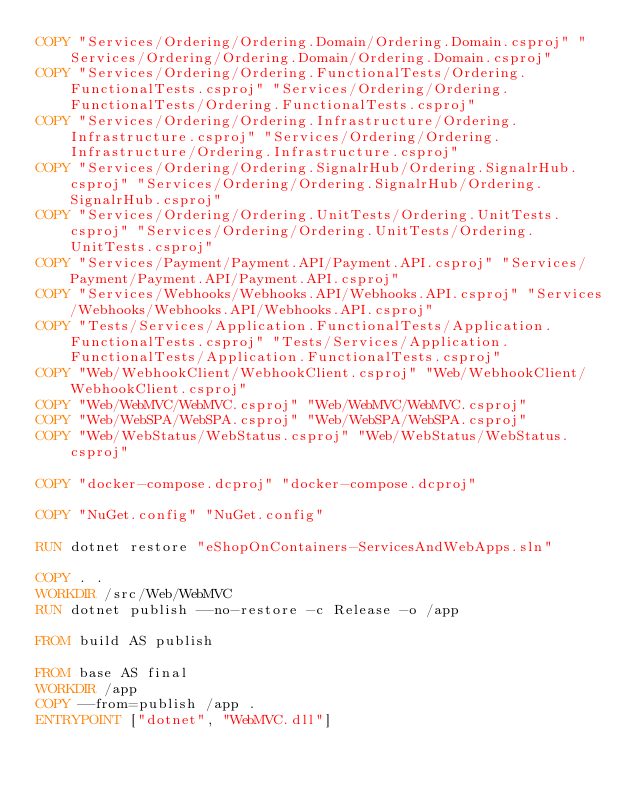<code> <loc_0><loc_0><loc_500><loc_500><_Dockerfile_>COPY "Services/Ordering/Ordering.Domain/Ordering.Domain.csproj" "Services/Ordering/Ordering.Domain/Ordering.Domain.csproj"
COPY "Services/Ordering/Ordering.FunctionalTests/Ordering.FunctionalTests.csproj" "Services/Ordering/Ordering.FunctionalTests/Ordering.FunctionalTests.csproj"
COPY "Services/Ordering/Ordering.Infrastructure/Ordering.Infrastructure.csproj" "Services/Ordering/Ordering.Infrastructure/Ordering.Infrastructure.csproj"
COPY "Services/Ordering/Ordering.SignalrHub/Ordering.SignalrHub.csproj" "Services/Ordering/Ordering.SignalrHub/Ordering.SignalrHub.csproj"
COPY "Services/Ordering/Ordering.UnitTests/Ordering.UnitTests.csproj" "Services/Ordering/Ordering.UnitTests/Ordering.UnitTests.csproj"
COPY "Services/Payment/Payment.API/Payment.API.csproj" "Services/Payment/Payment.API/Payment.API.csproj"
COPY "Services/Webhooks/Webhooks.API/Webhooks.API.csproj" "Services/Webhooks/Webhooks.API/Webhooks.API.csproj"
COPY "Tests/Services/Application.FunctionalTests/Application.FunctionalTests.csproj" "Tests/Services/Application.FunctionalTests/Application.FunctionalTests.csproj"
COPY "Web/WebhookClient/WebhookClient.csproj" "Web/WebhookClient/WebhookClient.csproj"
COPY "Web/WebMVC/WebMVC.csproj" "Web/WebMVC/WebMVC.csproj"
COPY "Web/WebSPA/WebSPA.csproj" "Web/WebSPA/WebSPA.csproj"
COPY "Web/WebStatus/WebStatus.csproj" "Web/WebStatus/WebStatus.csproj"

COPY "docker-compose.dcproj" "docker-compose.dcproj"

COPY "NuGet.config" "NuGet.config"

RUN dotnet restore "eShopOnContainers-ServicesAndWebApps.sln"

COPY . .
WORKDIR /src/Web/WebMVC
RUN dotnet publish --no-restore -c Release -o /app

FROM build AS publish

FROM base AS final
WORKDIR /app
COPY --from=publish /app .
ENTRYPOINT ["dotnet", "WebMVC.dll"]
</code> 